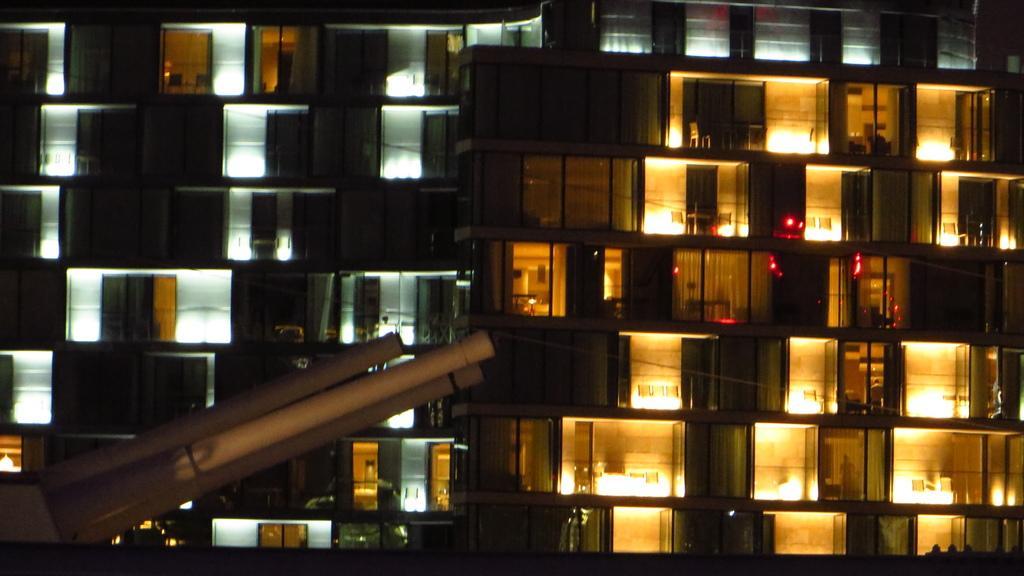Can you describe this image briefly? In front of the image there is an object, behind the object there is a building with glass walls, through the walls we can see objects and lights inside the rooms. 